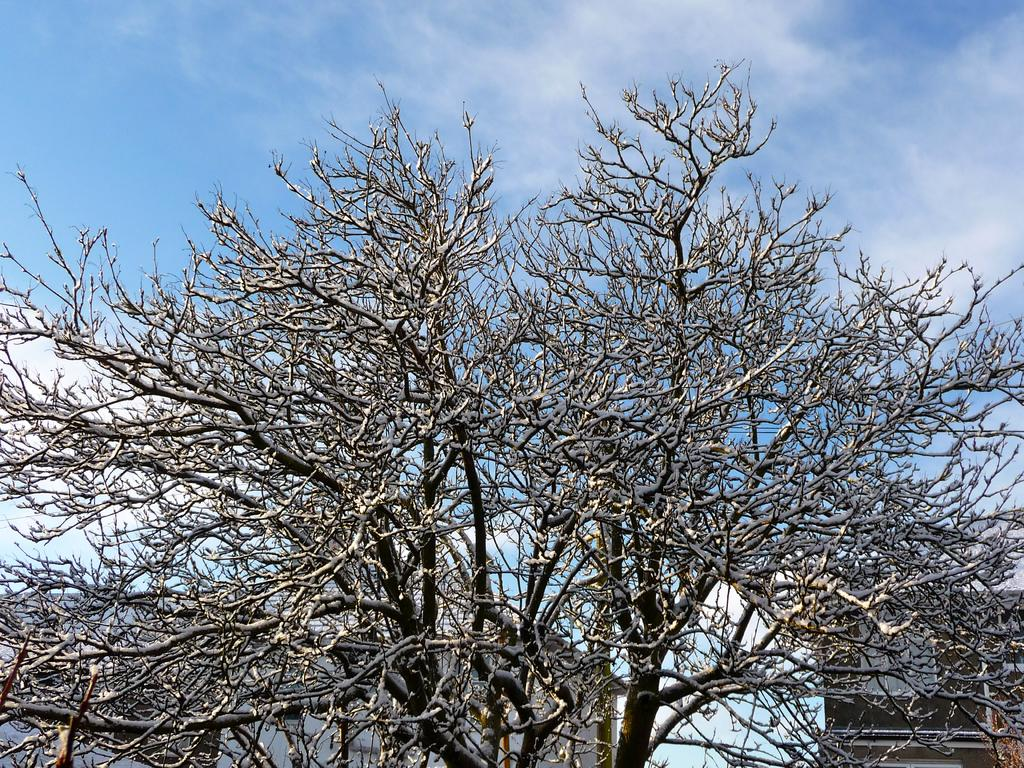What type of natural elements can be seen in the image? There are trees in the image. What else can be seen in the background of the image? There are objects visible in the background of the image. What part of the natural environment is visible in the image? The sky is visible in the background of the image. What is the condition of the sky in the image? Clouds are present in the sky. What type of hook can be seen hanging from the trees in the image? There is no hook present in the image; it only features trees and other unspecified objects in the background. 